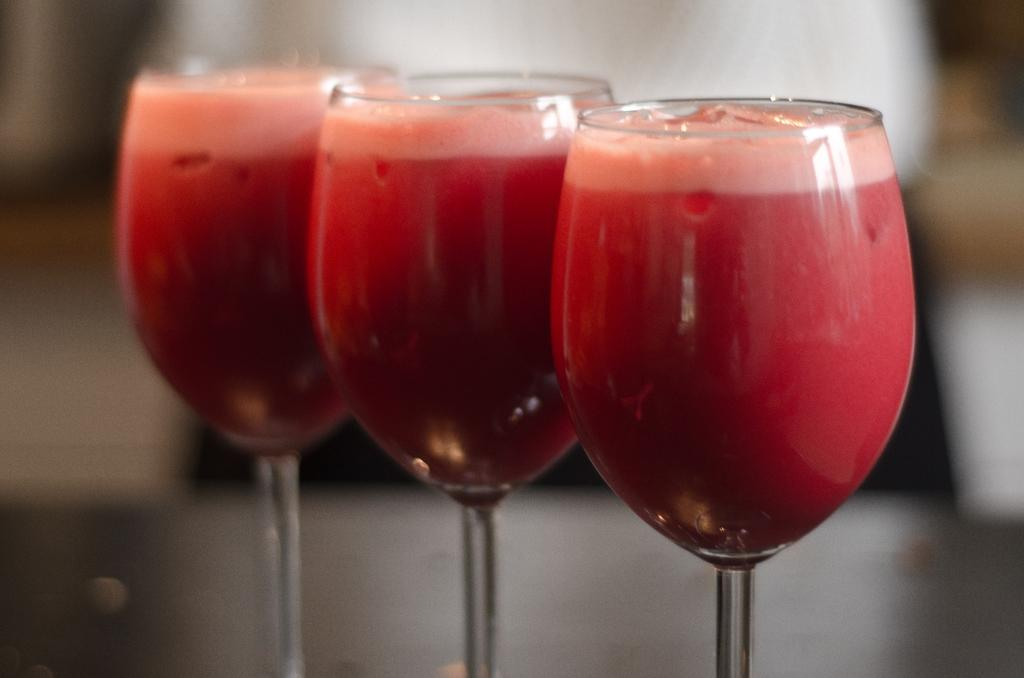How many wine glasses are visible in the image? There are 3 wine glasses in the image. What is inside the wine glasses? The wine glasses contain a drink. Can you describe the background of the image? The background of the image is blurred. What type of collar can be seen on the cave in the image? There is no cave present in the image, and therefore no collar can be seen on it. 